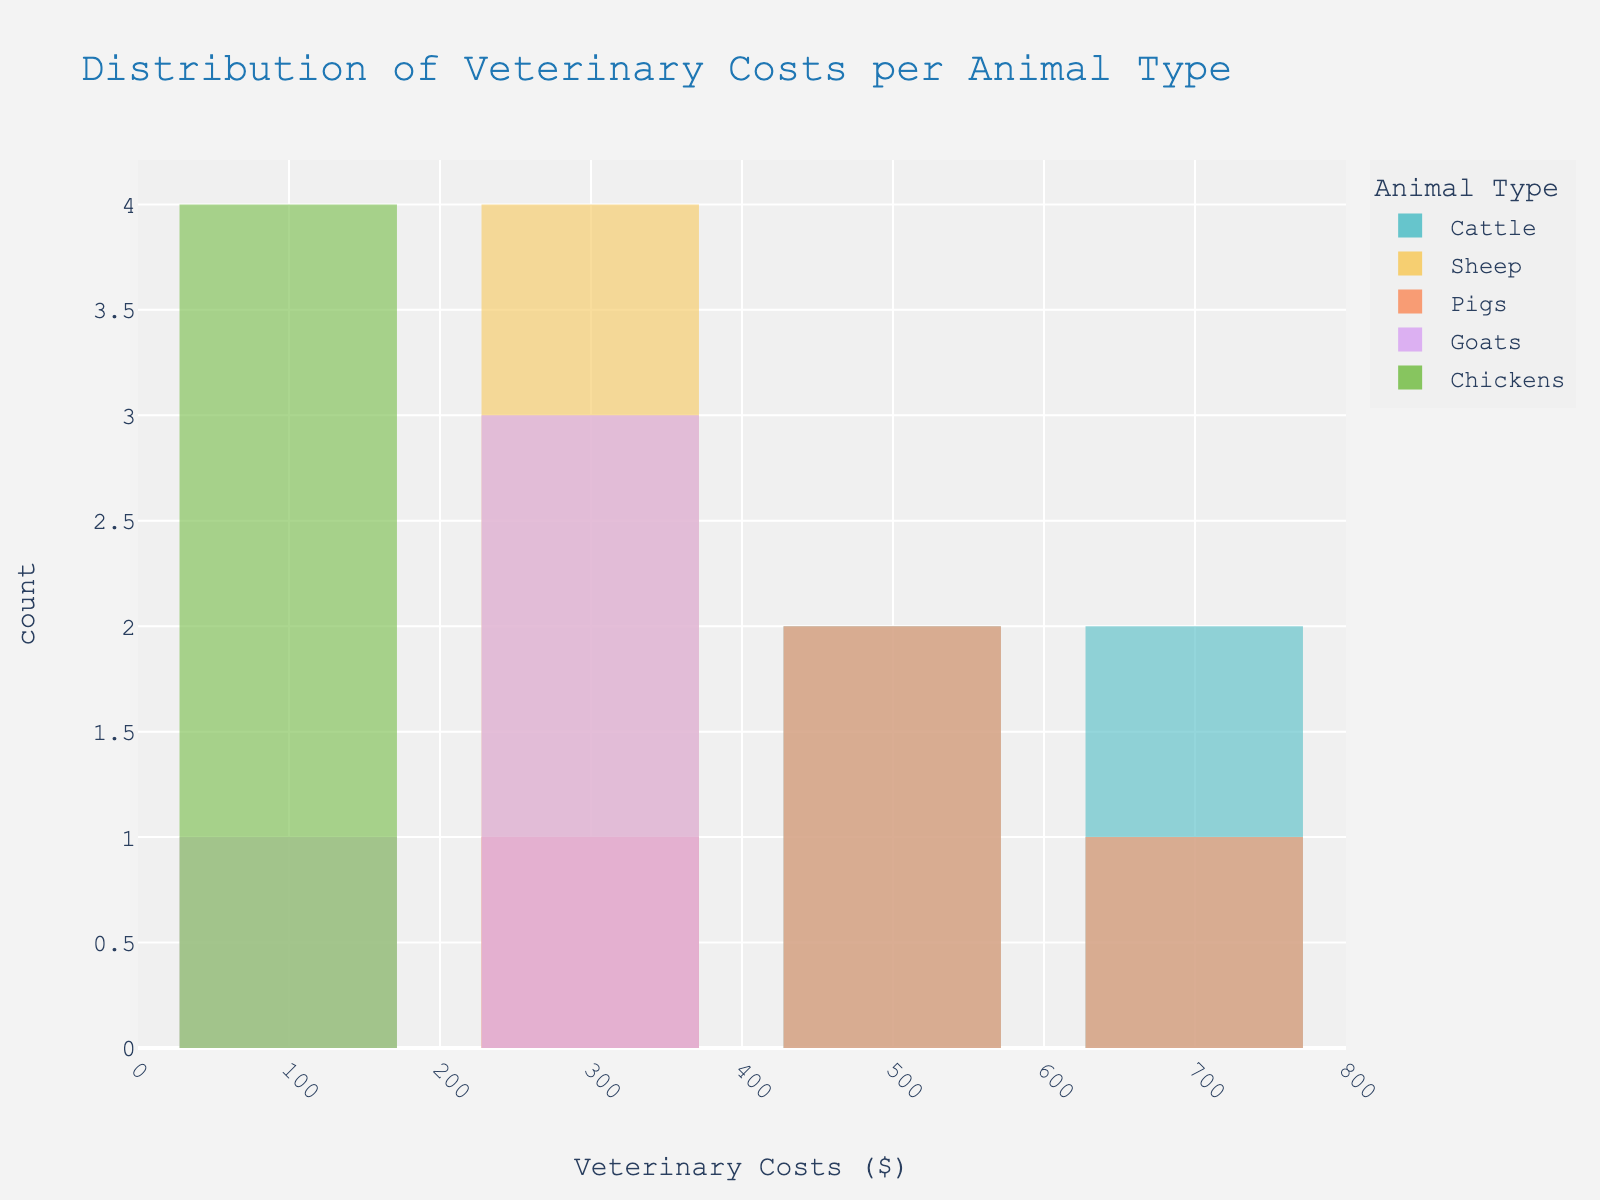What's the title of the histogram? The title of the histogram is prominently displayed at the top of the figure.
Answer: Distribution of Veterinary Costs per Animal Type How many types of animals are represented in the histogram? The legend or color encoding indicates the number of different animal types.
Answer: Five Which animal type has the highest veterinary cost recorded in the histogram? By examining the bars with the highest value on the x-axis, which extend farthest to the right.
Answer: Cattle What is the approximate range of veterinary costs for pigs? Look at the bars associated with pigs (color-coded) on the x-axis to determine the lowest and highest values.
Answer: $300 - $600 Which animal type has the lowest minimum veterinary cost? Identify the bar that starts at the lowest value on the x-axis and check its color for the associated animal type.
Answer: Chickens On average, do goats have higher or lower veterinary costs than sheep? Compare the central tendency (middle values) of the bars for goats and sheep.
Answer: Lower Which animal type appears to have the most uniform distribution of veterinary costs? Look for the animal type whose bars are most evenly spread out across their range.
Answer: Pigs What’s the median veterinary cost for cattle? Arrange the cattle costs in ascending order and find the middle value. The median is $600 as it is the middle value of the sorted cattle costs [450, 550, 650, 750].
Answer: $600 Among the animal types, which one has the narrowest spread of veterinary costs? Assess the range by comparing the difference between the maximum and minimum veterinary costs for each animal type.
Answer: Chickens Do any animal types share the same maximum veterinary cost? Which ones? Compare the highest veterinary costs for each animal type to see if any are equal.
Answer: No 